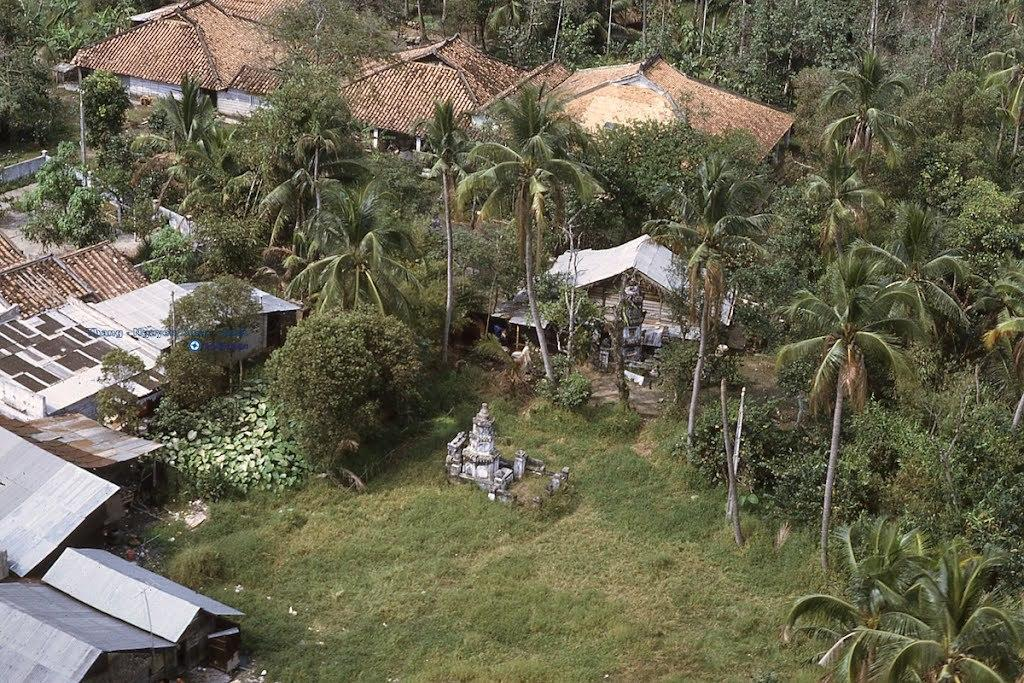What types of buildings are visible in the image? There are houses and huts in the image. What can be seen around the houses? There are many tall trees around the houses. What type of vegetation is present in the image? Grass is present in the image. What type of pot is being used in the class depicted in the image? There is no class or pot present in the image; it features houses, huts, and tall trees. 